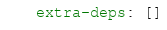<code> <loc_0><loc_0><loc_500><loc_500><_YAML_>
extra-deps: []</code> 